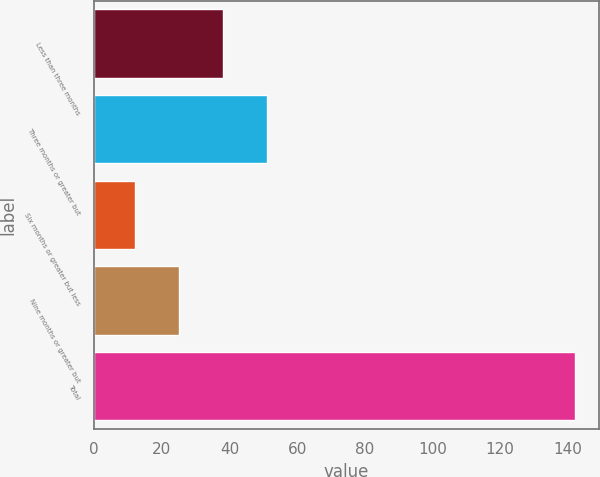<chart> <loc_0><loc_0><loc_500><loc_500><bar_chart><fcel>Less than three months<fcel>Three months or greater but<fcel>Six months or greater but less<fcel>Nine months or greater but<fcel>Total<nl><fcel>38<fcel>51<fcel>12<fcel>25<fcel>142<nl></chart> 